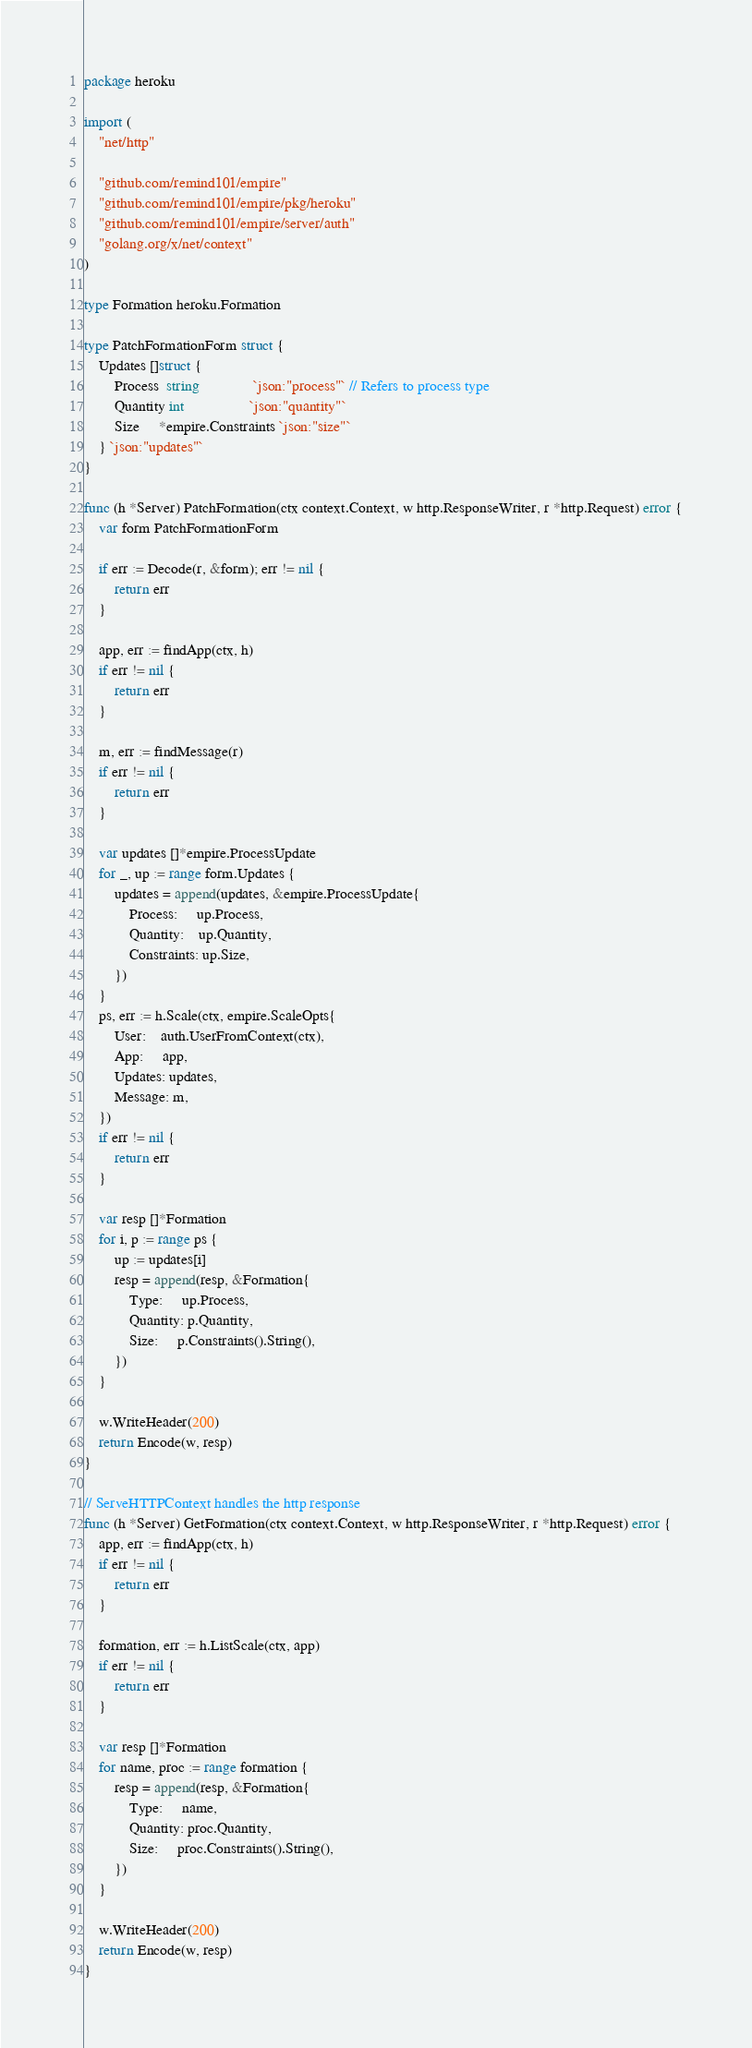<code> <loc_0><loc_0><loc_500><loc_500><_Go_>package heroku

import (
	"net/http"

	"github.com/remind101/empire"
	"github.com/remind101/empire/pkg/heroku"
	"github.com/remind101/empire/server/auth"
	"golang.org/x/net/context"
)

type Formation heroku.Formation

type PatchFormationForm struct {
	Updates []struct {
		Process  string              `json:"process"` // Refers to process type
		Quantity int                 `json:"quantity"`
		Size     *empire.Constraints `json:"size"`
	} `json:"updates"`
}

func (h *Server) PatchFormation(ctx context.Context, w http.ResponseWriter, r *http.Request) error {
	var form PatchFormationForm

	if err := Decode(r, &form); err != nil {
		return err
	}

	app, err := findApp(ctx, h)
	if err != nil {
		return err
	}

	m, err := findMessage(r)
	if err != nil {
		return err
	}

	var updates []*empire.ProcessUpdate
	for _, up := range form.Updates {
		updates = append(updates, &empire.ProcessUpdate{
			Process:     up.Process,
			Quantity:    up.Quantity,
			Constraints: up.Size,
		})
	}
	ps, err := h.Scale(ctx, empire.ScaleOpts{
		User:    auth.UserFromContext(ctx),
		App:     app,
		Updates: updates,
		Message: m,
	})
	if err != nil {
		return err
	}

	var resp []*Formation
	for i, p := range ps {
		up := updates[i]
		resp = append(resp, &Formation{
			Type:     up.Process,
			Quantity: p.Quantity,
			Size:     p.Constraints().String(),
		})
	}

	w.WriteHeader(200)
	return Encode(w, resp)
}

// ServeHTTPContext handles the http response
func (h *Server) GetFormation(ctx context.Context, w http.ResponseWriter, r *http.Request) error {
	app, err := findApp(ctx, h)
	if err != nil {
		return err
	}

	formation, err := h.ListScale(ctx, app)
	if err != nil {
		return err
	}

	var resp []*Formation
	for name, proc := range formation {
		resp = append(resp, &Formation{
			Type:     name,
			Quantity: proc.Quantity,
			Size:     proc.Constraints().String(),
		})
	}

	w.WriteHeader(200)
	return Encode(w, resp)
}
</code> 